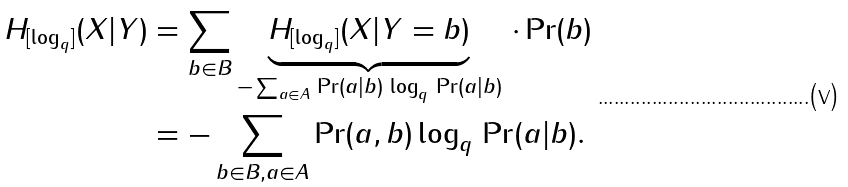<formula> <loc_0><loc_0><loc_500><loc_500>H _ { [ \log _ { q } ] } ( X | Y ) & = \sum _ { b \in B } \underbrace { H _ { [ \log _ { q } ] } ( X | Y = b ) } _ { - \sum _ { a \in A } \, \Pr ( a | b ) \, \log _ { q } \, \Pr ( a | b ) } \, \cdot \Pr ( b ) \\ & = - \sum _ { b \in B , a \in A } \Pr ( a , b ) \log _ { q } \, \Pr ( a | b ) .</formula> 